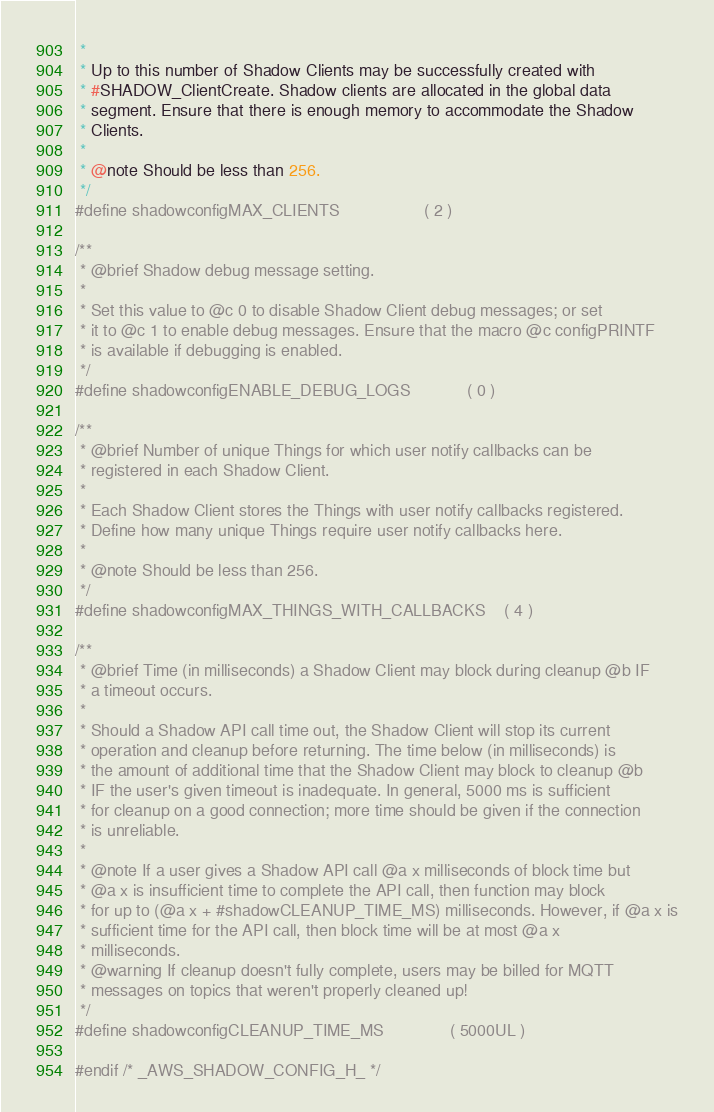<code> <loc_0><loc_0><loc_500><loc_500><_C_> *
 * Up to this number of Shadow Clients may be successfully created with
 * #SHADOW_ClientCreate. Shadow clients are allocated in the global data
 * segment. Ensure that there is enough memory to accommodate the Shadow
 * Clients.
 *
 * @note Should be less than 256.
 */
#define shadowconfigMAX_CLIENTS                  ( 2 )

/**
 * @brief Shadow debug message setting.
 *
 * Set this value to @c 0 to disable Shadow Client debug messages; or set
 * it to @c 1 to enable debug messages. Ensure that the macro @c configPRINTF
 * is available if debugging is enabled.
 */
#define shadowconfigENABLE_DEBUG_LOGS            ( 0 )

/**
 * @brief Number of unique Things for which user notify callbacks can be
 * registered in each Shadow Client.
 *
 * Each Shadow Client stores the Things with user notify callbacks registered.
 * Define how many unique Things require user notify callbacks here.
 *
 * @note Should be less than 256.
 */
#define shadowconfigMAX_THINGS_WITH_CALLBACKS    ( 4 )

/**
 * @brief Time (in milliseconds) a Shadow Client may block during cleanup @b IF
 * a timeout occurs.
 *
 * Should a Shadow API call time out, the Shadow Client will stop its current
 * operation and cleanup before returning. The time below (in milliseconds) is
 * the amount of additional time that the Shadow Client may block to cleanup @b
 * IF the user's given timeout is inadequate. In general, 5000 ms is sufficient
 * for cleanup on a good connection; more time should be given if the connection
 * is unreliable.
 *
 * @note If a user gives a Shadow API call @a x milliseconds of block time but
 * @a x is insufficient time to complete the API call, then function may block
 * for up to (@a x + #shadowCLEANUP_TIME_MS) milliseconds. However, if @a x is
 * sufficient time for the API call, then block time will be at most @a x
 * milliseconds.
 * @warning If cleanup doesn't fully complete, users may be billed for MQTT
 * messages on topics that weren't properly cleaned up!
 */
#define shadowconfigCLEANUP_TIME_MS              ( 5000UL )

#endif /* _AWS_SHADOW_CONFIG_H_ */</code> 